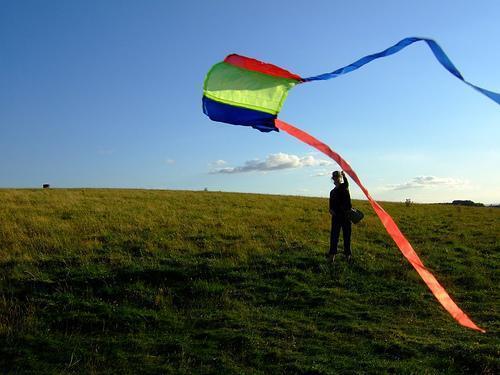How many cars in this picture are white?
Give a very brief answer. 0. 